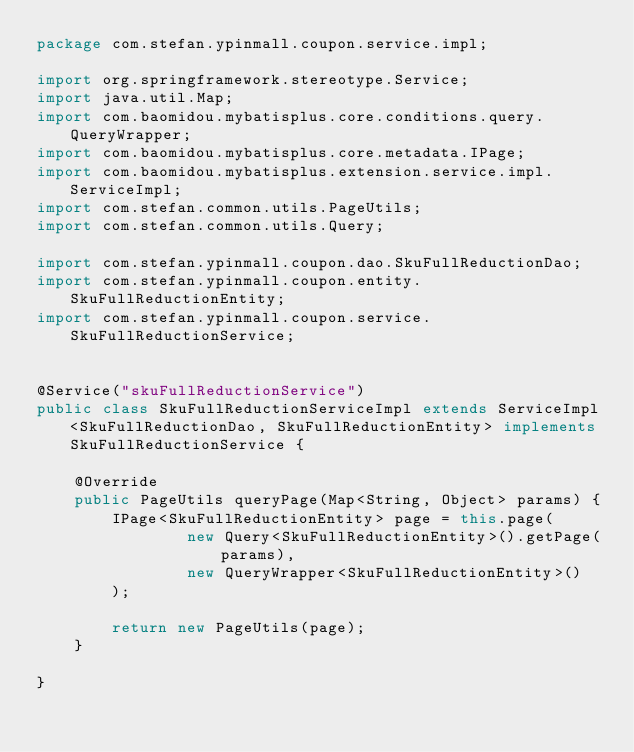<code> <loc_0><loc_0><loc_500><loc_500><_Java_>package com.stefan.ypinmall.coupon.service.impl;

import org.springframework.stereotype.Service;
import java.util.Map;
import com.baomidou.mybatisplus.core.conditions.query.QueryWrapper;
import com.baomidou.mybatisplus.core.metadata.IPage;
import com.baomidou.mybatisplus.extension.service.impl.ServiceImpl;
import com.stefan.common.utils.PageUtils;
import com.stefan.common.utils.Query;

import com.stefan.ypinmall.coupon.dao.SkuFullReductionDao;
import com.stefan.ypinmall.coupon.entity.SkuFullReductionEntity;
import com.stefan.ypinmall.coupon.service.SkuFullReductionService;


@Service("skuFullReductionService")
public class SkuFullReductionServiceImpl extends ServiceImpl<SkuFullReductionDao, SkuFullReductionEntity> implements SkuFullReductionService {

    @Override
    public PageUtils queryPage(Map<String, Object> params) {
        IPage<SkuFullReductionEntity> page = this.page(
                new Query<SkuFullReductionEntity>().getPage(params),
                new QueryWrapper<SkuFullReductionEntity>()
        );

        return new PageUtils(page);
    }

}</code> 